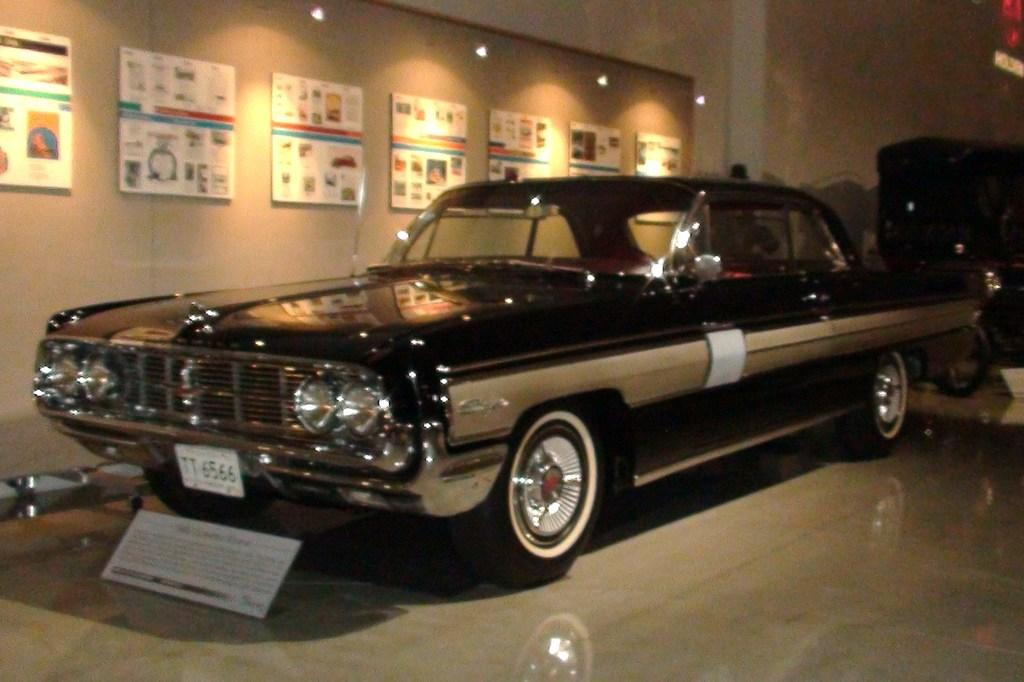What type of vehicle is featured in the image? There is a vintage car in the image. How is the vintage car being presented? The vintage car is on display. Is there any additional information provided about the car? Yes, there is a descriptive note in front of the car. What can be seen on the wall beside the car? There are posters on the wall beside the car. What type of shade does the band use to protect themselves from the sun in the image? There is no band or shade present in the image; it features a vintage car on display with a descriptive note and posters on the wall. 